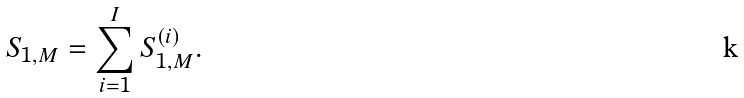Convert formula to latex. <formula><loc_0><loc_0><loc_500><loc_500>S _ { 1 , M } = \sum _ { i = 1 } ^ { I } S _ { 1 , M } ^ { ( i ) } .</formula> 